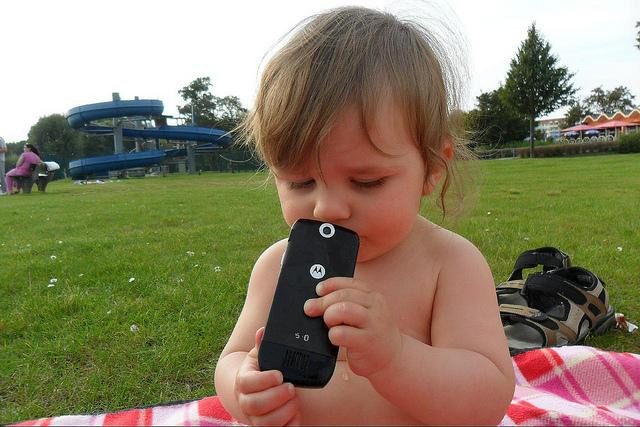What is playing with the phone? Please explain your reasoning. baby. The baby plays. 